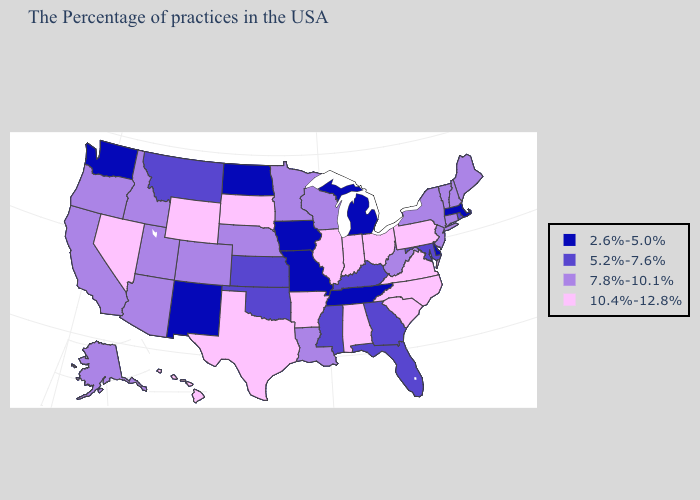What is the value of Kentucky?
Give a very brief answer. 5.2%-7.6%. Name the states that have a value in the range 7.8%-10.1%?
Give a very brief answer. Maine, New Hampshire, Vermont, Connecticut, New York, New Jersey, West Virginia, Wisconsin, Louisiana, Minnesota, Nebraska, Colorado, Utah, Arizona, Idaho, California, Oregon, Alaska. What is the value of Wyoming?
Be succinct. 10.4%-12.8%. Does California have the lowest value in the USA?
Quick response, please. No. What is the value of New York?
Give a very brief answer. 7.8%-10.1%. Does Hawaii have the same value as North Carolina?
Write a very short answer. Yes. Name the states that have a value in the range 2.6%-5.0%?
Write a very short answer. Massachusetts, Delaware, Michigan, Tennessee, Missouri, Iowa, North Dakota, New Mexico, Washington. Does New Mexico have the same value as Louisiana?
Concise answer only. No. Name the states that have a value in the range 10.4%-12.8%?
Write a very short answer. Pennsylvania, Virginia, North Carolina, South Carolina, Ohio, Indiana, Alabama, Illinois, Arkansas, Texas, South Dakota, Wyoming, Nevada, Hawaii. Which states have the highest value in the USA?
Write a very short answer. Pennsylvania, Virginia, North Carolina, South Carolina, Ohio, Indiana, Alabama, Illinois, Arkansas, Texas, South Dakota, Wyoming, Nevada, Hawaii. What is the lowest value in the MidWest?
Be succinct. 2.6%-5.0%. Does Maryland have a lower value than Illinois?
Quick response, please. Yes. Does Nevada have the same value as Oklahoma?
Give a very brief answer. No. What is the highest value in the USA?
Give a very brief answer. 10.4%-12.8%. What is the lowest value in states that border Minnesota?
Answer briefly. 2.6%-5.0%. 